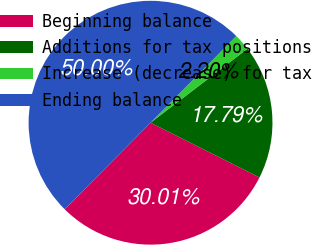Convert chart. <chart><loc_0><loc_0><loc_500><loc_500><pie_chart><fcel>Beginning balance<fcel>Additions for tax positions<fcel>Increase (decrease) for tax<fcel>Ending balance<nl><fcel>30.01%<fcel>17.79%<fcel>2.2%<fcel>50.0%<nl></chart> 